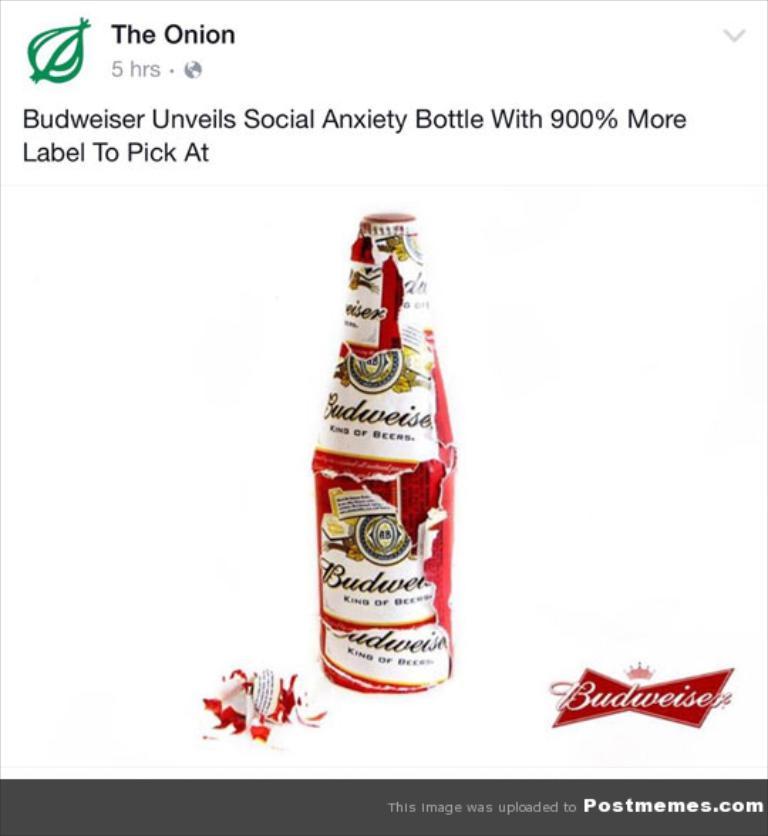What news outlet published this story?
Your answer should be compact. The onion. What is the name of this beer?
Ensure brevity in your answer.  Budweiser. 